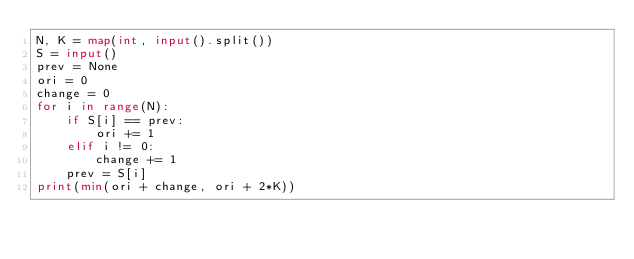Convert code to text. <code><loc_0><loc_0><loc_500><loc_500><_Python_>N, K = map(int, input().split())
S = input()
prev = None
ori = 0
change = 0
for i in range(N):
    if S[i] == prev:
        ori += 1
    elif i != 0:
        change += 1
    prev = S[i]
print(min(ori + change, ori + 2*K))</code> 